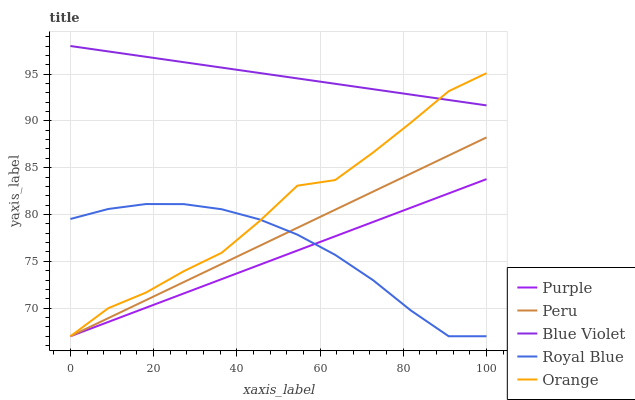Does Purple have the minimum area under the curve?
Answer yes or no. Yes. Does Blue Violet have the maximum area under the curve?
Answer yes or no. Yes. Does Royal Blue have the minimum area under the curve?
Answer yes or no. No. Does Royal Blue have the maximum area under the curve?
Answer yes or no. No. Is Blue Violet the smoothest?
Answer yes or no. Yes. Is Orange the roughest?
Answer yes or no. Yes. Is Royal Blue the smoothest?
Answer yes or no. No. Is Royal Blue the roughest?
Answer yes or no. No. Does Purple have the lowest value?
Answer yes or no. Yes. Does Blue Violet have the lowest value?
Answer yes or no. No. Does Blue Violet have the highest value?
Answer yes or no. Yes. Does Orange have the highest value?
Answer yes or no. No. Is Purple less than Blue Violet?
Answer yes or no. Yes. Is Blue Violet greater than Peru?
Answer yes or no. Yes. Does Royal Blue intersect Purple?
Answer yes or no. Yes. Is Royal Blue less than Purple?
Answer yes or no. No. Is Royal Blue greater than Purple?
Answer yes or no. No. Does Purple intersect Blue Violet?
Answer yes or no. No. 